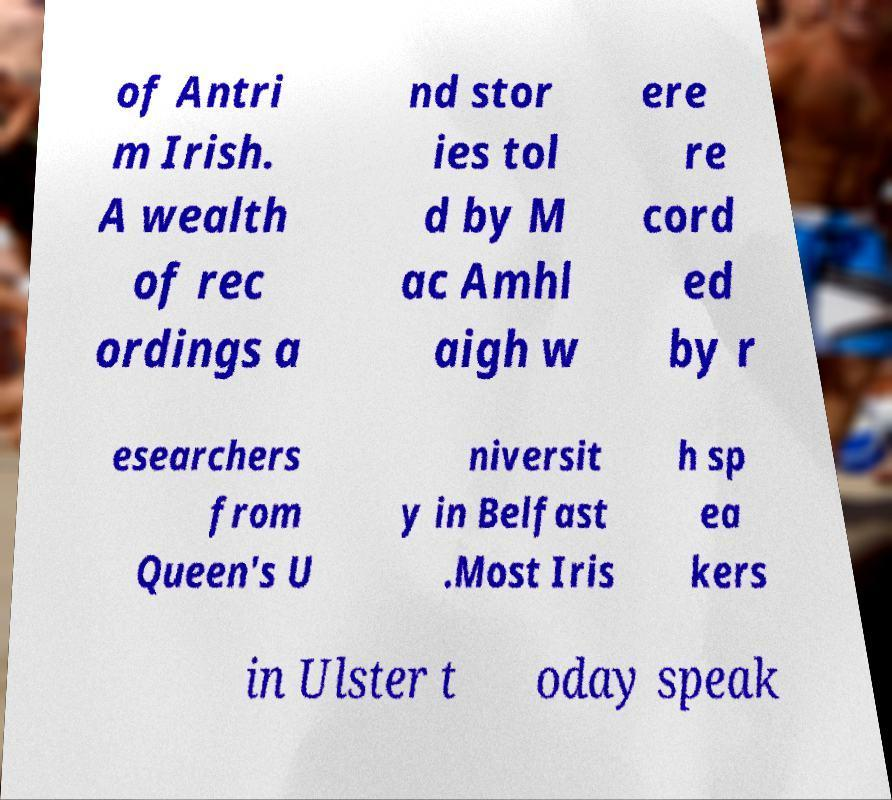What messages or text are displayed in this image? I need them in a readable, typed format. of Antri m Irish. A wealth of rec ordings a nd stor ies tol d by M ac Amhl aigh w ere re cord ed by r esearchers from Queen's U niversit y in Belfast .Most Iris h sp ea kers in Ulster t oday speak 